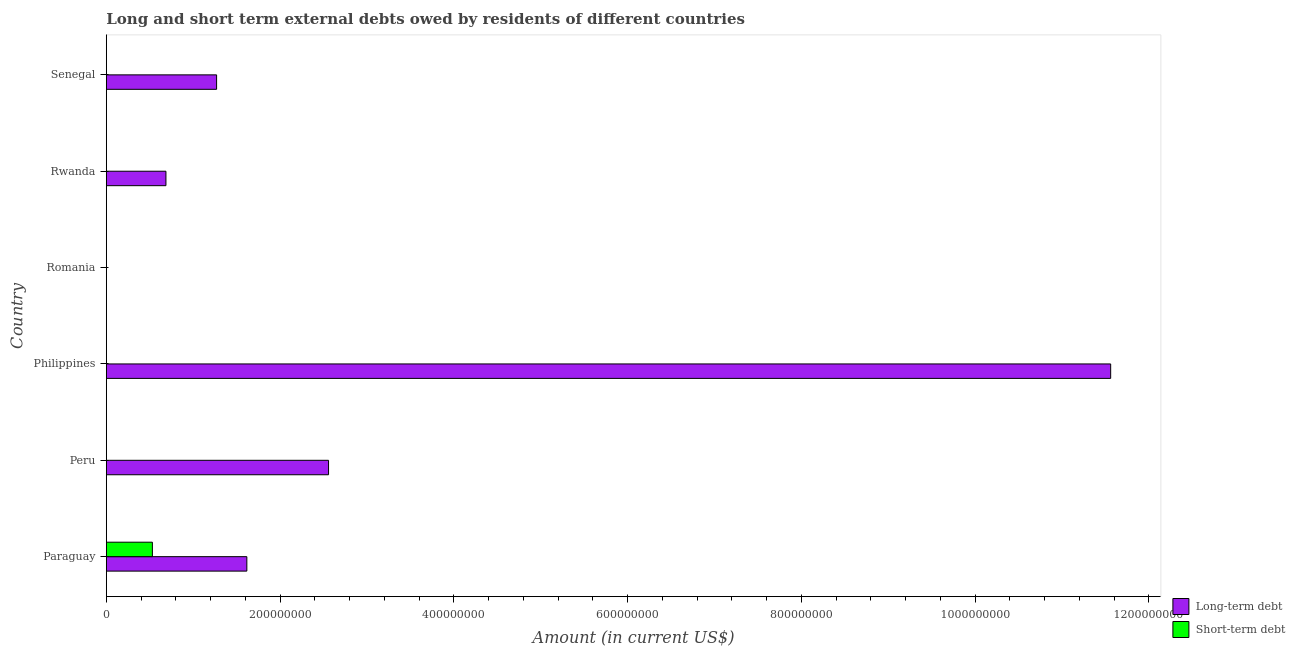How many different coloured bars are there?
Provide a short and direct response. 2. Are the number of bars per tick equal to the number of legend labels?
Offer a very short reply. No. How many bars are there on the 2nd tick from the top?
Give a very brief answer. 1. How many bars are there on the 6th tick from the bottom?
Your answer should be compact. 1. What is the label of the 2nd group of bars from the top?
Provide a short and direct response. Rwanda. What is the short-term debts owed by residents in Romania?
Your answer should be compact. 0. Across all countries, what is the maximum long-term debts owed by residents?
Make the answer very short. 1.16e+09. In which country was the long-term debts owed by residents maximum?
Provide a succinct answer. Philippines. What is the total short-term debts owed by residents in the graph?
Your response must be concise. 5.30e+07. What is the difference between the long-term debts owed by residents in Paraguay and that in Senegal?
Provide a succinct answer. 3.48e+07. What is the difference between the short-term debts owed by residents in Paraguay and the long-term debts owed by residents in Rwanda?
Your answer should be very brief. -1.56e+07. What is the average long-term debts owed by residents per country?
Ensure brevity in your answer.  2.95e+08. What is the difference between the long-term debts owed by residents and short-term debts owed by residents in Paraguay?
Make the answer very short. 1.09e+08. In how many countries, is the short-term debts owed by residents greater than 120000000 US$?
Provide a succinct answer. 0. What is the ratio of the long-term debts owed by residents in Paraguay to that in Philippines?
Your response must be concise. 0.14. Is the long-term debts owed by residents in Paraguay less than that in Rwanda?
Your answer should be very brief. No. What is the difference between the highest and the second highest long-term debts owed by residents?
Keep it short and to the point. 9.00e+08. What is the difference between the highest and the lowest long-term debts owed by residents?
Offer a very short reply. 1.16e+09. In how many countries, is the long-term debts owed by residents greater than the average long-term debts owed by residents taken over all countries?
Provide a short and direct response. 1. How many bars are there?
Give a very brief answer. 6. What is the difference between two consecutive major ticks on the X-axis?
Give a very brief answer. 2.00e+08. Does the graph contain any zero values?
Provide a succinct answer. Yes. How are the legend labels stacked?
Provide a succinct answer. Vertical. What is the title of the graph?
Your answer should be very brief. Long and short term external debts owed by residents of different countries. What is the label or title of the X-axis?
Give a very brief answer. Amount (in current US$). What is the Amount (in current US$) of Long-term debt in Paraguay?
Your answer should be very brief. 1.62e+08. What is the Amount (in current US$) of Short-term debt in Paraguay?
Provide a succinct answer. 5.30e+07. What is the Amount (in current US$) in Long-term debt in Peru?
Your response must be concise. 2.56e+08. What is the Amount (in current US$) in Short-term debt in Peru?
Your answer should be compact. 0. What is the Amount (in current US$) in Long-term debt in Philippines?
Your answer should be very brief. 1.16e+09. What is the Amount (in current US$) in Short-term debt in Philippines?
Provide a short and direct response. 0. What is the Amount (in current US$) in Short-term debt in Romania?
Ensure brevity in your answer.  0. What is the Amount (in current US$) of Long-term debt in Rwanda?
Provide a succinct answer. 6.86e+07. What is the Amount (in current US$) in Long-term debt in Senegal?
Your answer should be compact. 1.27e+08. Across all countries, what is the maximum Amount (in current US$) in Long-term debt?
Your answer should be compact. 1.16e+09. Across all countries, what is the maximum Amount (in current US$) in Short-term debt?
Provide a succinct answer. 5.30e+07. What is the total Amount (in current US$) in Long-term debt in the graph?
Ensure brevity in your answer.  1.77e+09. What is the total Amount (in current US$) of Short-term debt in the graph?
Make the answer very short. 5.30e+07. What is the difference between the Amount (in current US$) of Long-term debt in Paraguay and that in Peru?
Your response must be concise. -9.40e+07. What is the difference between the Amount (in current US$) of Long-term debt in Paraguay and that in Philippines?
Ensure brevity in your answer.  -9.94e+08. What is the difference between the Amount (in current US$) in Long-term debt in Paraguay and that in Rwanda?
Your answer should be compact. 9.31e+07. What is the difference between the Amount (in current US$) of Long-term debt in Paraguay and that in Senegal?
Your response must be concise. 3.48e+07. What is the difference between the Amount (in current US$) in Long-term debt in Peru and that in Philippines?
Your answer should be very brief. -9.00e+08. What is the difference between the Amount (in current US$) of Long-term debt in Peru and that in Rwanda?
Ensure brevity in your answer.  1.87e+08. What is the difference between the Amount (in current US$) of Long-term debt in Peru and that in Senegal?
Provide a succinct answer. 1.29e+08. What is the difference between the Amount (in current US$) of Long-term debt in Philippines and that in Rwanda?
Make the answer very short. 1.09e+09. What is the difference between the Amount (in current US$) of Long-term debt in Philippines and that in Senegal?
Ensure brevity in your answer.  1.03e+09. What is the difference between the Amount (in current US$) of Long-term debt in Rwanda and that in Senegal?
Provide a short and direct response. -5.83e+07. What is the average Amount (in current US$) of Long-term debt per country?
Provide a succinct answer. 2.95e+08. What is the average Amount (in current US$) in Short-term debt per country?
Offer a very short reply. 8.83e+06. What is the difference between the Amount (in current US$) of Long-term debt and Amount (in current US$) of Short-term debt in Paraguay?
Keep it short and to the point. 1.09e+08. What is the ratio of the Amount (in current US$) of Long-term debt in Paraguay to that in Peru?
Make the answer very short. 0.63. What is the ratio of the Amount (in current US$) of Long-term debt in Paraguay to that in Philippines?
Provide a succinct answer. 0.14. What is the ratio of the Amount (in current US$) of Long-term debt in Paraguay to that in Rwanda?
Offer a very short reply. 2.36. What is the ratio of the Amount (in current US$) in Long-term debt in Paraguay to that in Senegal?
Provide a succinct answer. 1.27. What is the ratio of the Amount (in current US$) of Long-term debt in Peru to that in Philippines?
Make the answer very short. 0.22. What is the ratio of the Amount (in current US$) of Long-term debt in Peru to that in Rwanda?
Keep it short and to the point. 3.73. What is the ratio of the Amount (in current US$) of Long-term debt in Peru to that in Senegal?
Provide a succinct answer. 2.02. What is the ratio of the Amount (in current US$) of Long-term debt in Philippines to that in Rwanda?
Offer a terse response. 16.85. What is the ratio of the Amount (in current US$) of Long-term debt in Philippines to that in Senegal?
Give a very brief answer. 9.11. What is the ratio of the Amount (in current US$) in Long-term debt in Rwanda to that in Senegal?
Offer a terse response. 0.54. What is the difference between the highest and the second highest Amount (in current US$) in Long-term debt?
Your answer should be compact. 9.00e+08. What is the difference between the highest and the lowest Amount (in current US$) of Long-term debt?
Your response must be concise. 1.16e+09. What is the difference between the highest and the lowest Amount (in current US$) of Short-term debt?
Provide a succinct answer. 5.30e+07. 